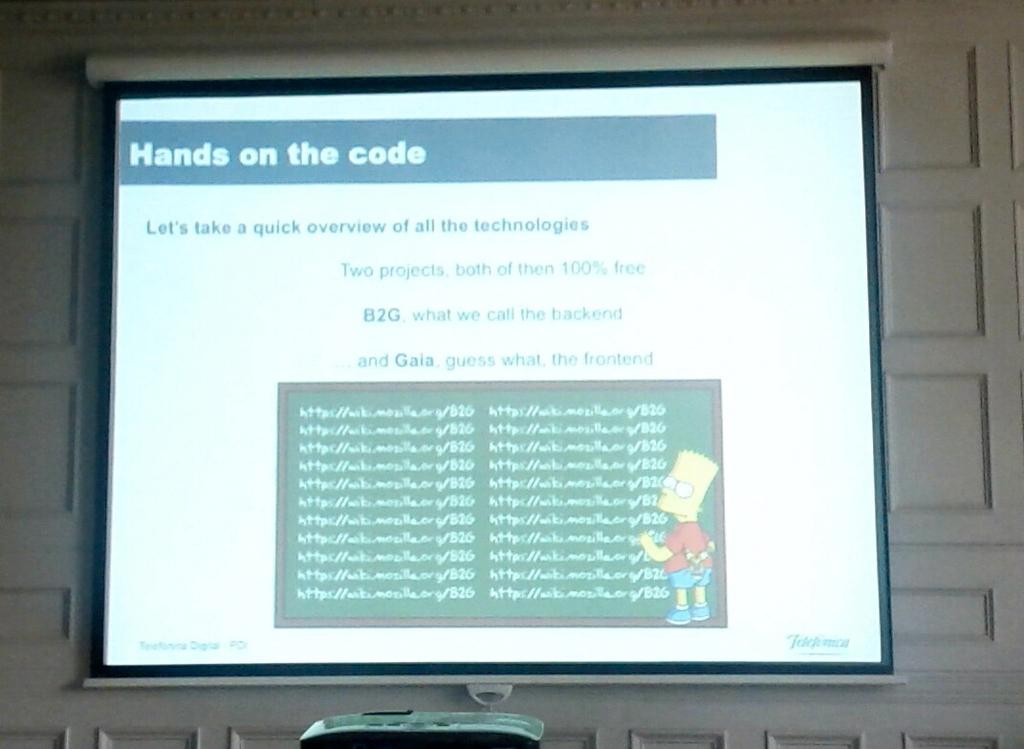What are on the code?
Your answer should be very brief. Hands. What does it say to take a quick overview of?
Your response must be concise. All the technologies. 